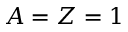Convert formula to latex. <formula><loc_0><loc_0><loc_500><loc_500>A = Z = 1</formula> 